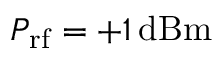<formula> <loc_0><loc_0><loc_500><loc_500>P _ { r f } = + 1 \, d B m</formula> 